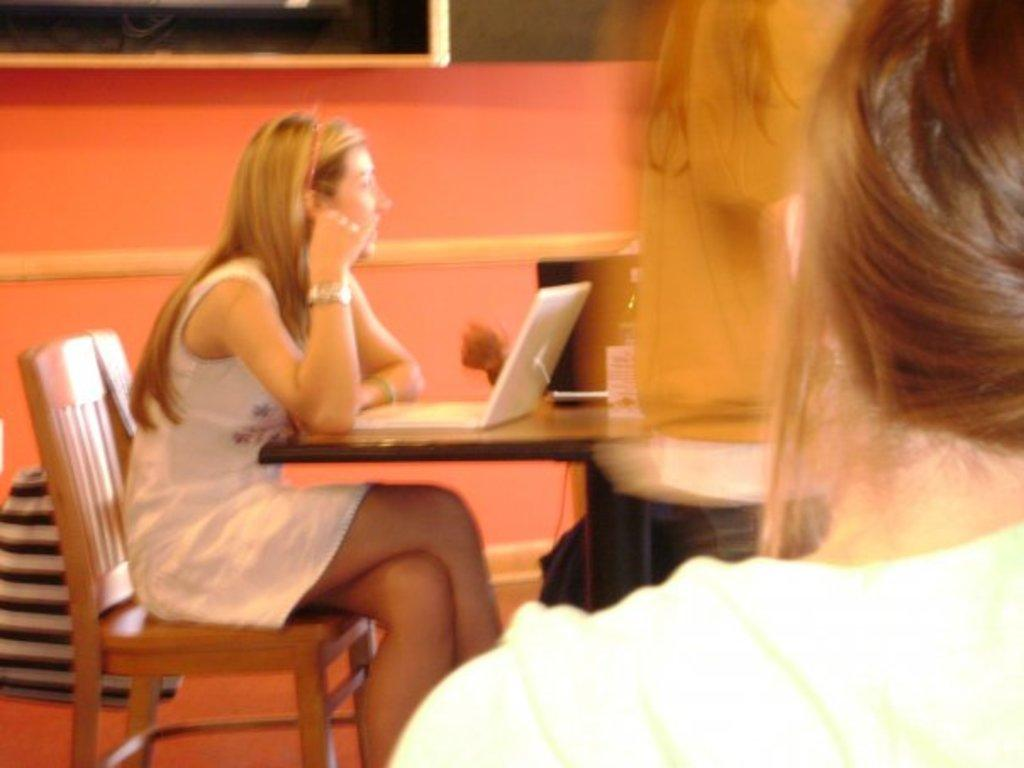What is the person in the image doing? The person is sitting on a chair in the image. What object is present on the table in the image? There is a laptop on the table in the image. What can be seen in the background of the image? There is a curtain and a photo frame in the background. What type of robin is perched on the laptop in the image? There is no robin present in the image; it only features a person sitting on a chair and a laptop on a table. 